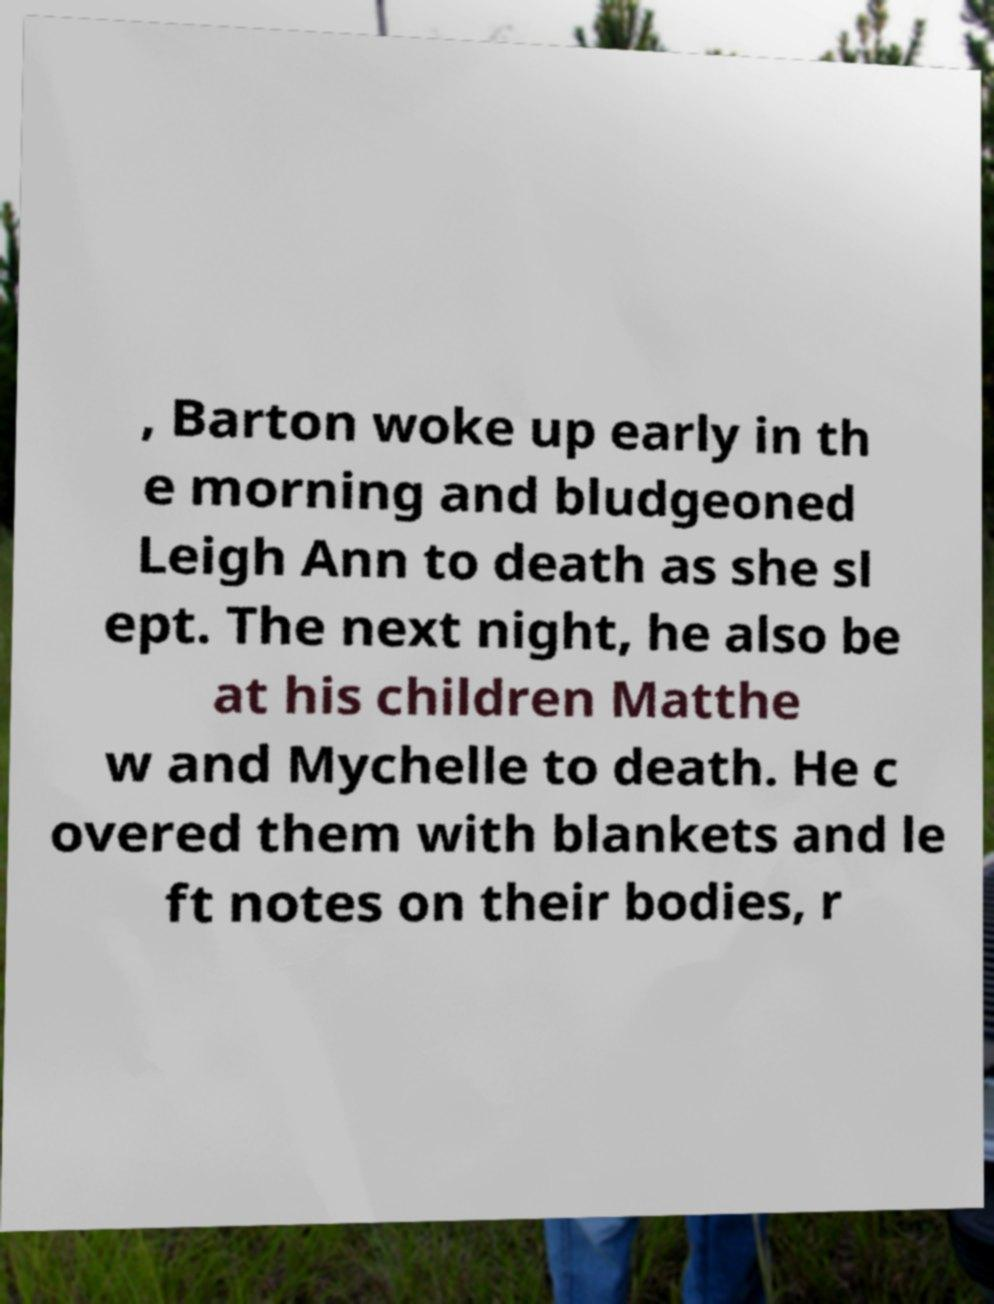There's text embedded in this image that I need extracted. Can you transcribe it verbatim? , Barton woke up early in th e morning and bludgeoned Leigh Ann to death as she sl ept. The next night, he also be at his children Matthe w and Mychelle to death. He c overed them with blankets and le ft notes on their bodies, r 